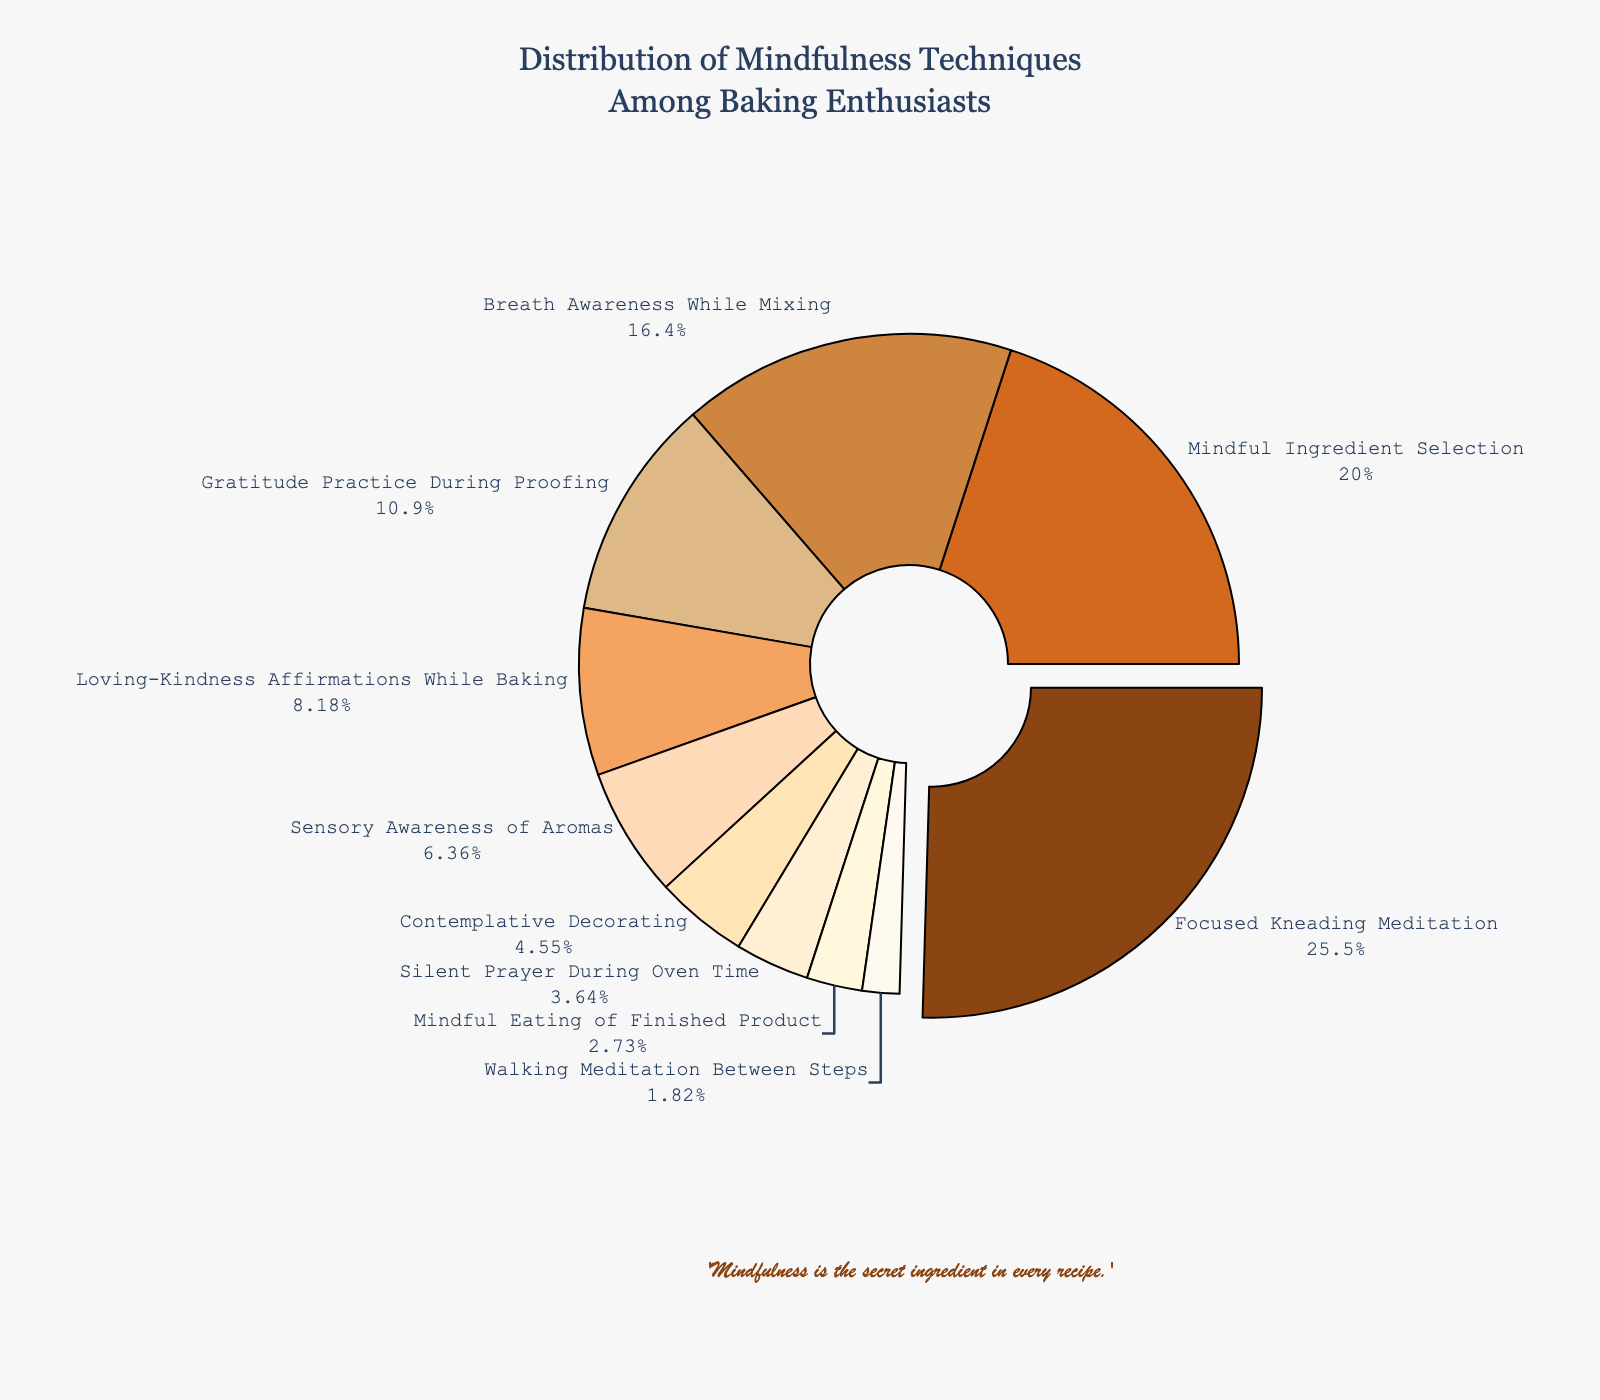Which mindfulness technique is the most preferred among baking enthusiasts? The pie chart highlights the slice with "Focused Kneading Meditation," which is pulled out slightly and labeled with the highest percentage.
Answer: Focused Kneading Meditation Which two mindfulness techniques combined make up more than half of the total preferences? By adding the percentages of "Focused Kneading Meditation" (28%) and "Mindful Ingredient Selection" (22%), the sum is 50%, indicating that these two techniques together account for exactly half the total preferences.
Answer: Focused Kneading Meditation and Mindful Ingredient Selection How does the popularity of "Gratitude Practice During Proofing" compare to "Loving-Kindness Affirmations While Baking"? The pie chart shows "Gratitude Practice During Proofing" with a higher percentage (12%) compared to "Loving-Kindness Affirmations While Baking" (9%).
Answer: Gratitude Practice During Proofing is more popular What percentage of enthusiasts prefer techniques related to mixing or kneading? Adding the percentages of "Focused Kneading Meditation" (28%) and "Breath Awareness While Mixing" (18%), the total is 46%.
Answer: 46% Is "Contemplative Decorating" more or less popular than "Sensory Awareness of Aromas"? According to the pie chart, "Contemplative Decorating" has a smaller percentage (5%) compared to "Sensory Awareness of Aromas" (7%).
Answer: Less popular How does the preference for "Mindful Eating of Finished Product" compare to "Walking Meditation Between Steps"? The pie chart indicates that "Mindful Eating of Finished Product" has a higher percentage (3%) compared to "Walking Meditation Between Steps" (2%).
Answer: Mindful Eating of Finished Product is more popular What visual cues indicate the most preferred mindfulness technique? The slice labeled "Focused Kneading Meditation" is visually pulled out slightly from the pie chart and marked with the highest percentage of 28%.
Answer: Pulled out slice with highest percentage Which mindfulness technique has the least preference among enthusiasts? The smallest slice on the pie chart is labeled "Walking Meditation Between Steps" with a percentage of 2%.
Answer: Walking Meditation Between Steps What is the combined percentage of the three least preferred techniques? Adding the percentages of "Walking Meditation Between Steps" (2%), "Mindful Eating of Finished Product" (3%), and "Silent Prayer During Oven Time" (4%), the total sum is 9%.
Answer: 9% Compare the preference for "Sensory Awareness of Aromas" to "Gratitude Practice During Proofing" and state the difference in percentage. The pie chart shows "Sensory Awareness of Aromas" at 7% and "Gratitude Practice During Proofing" at 12%. The difference is 12% - 7% = 5%.
Answer: 5% 